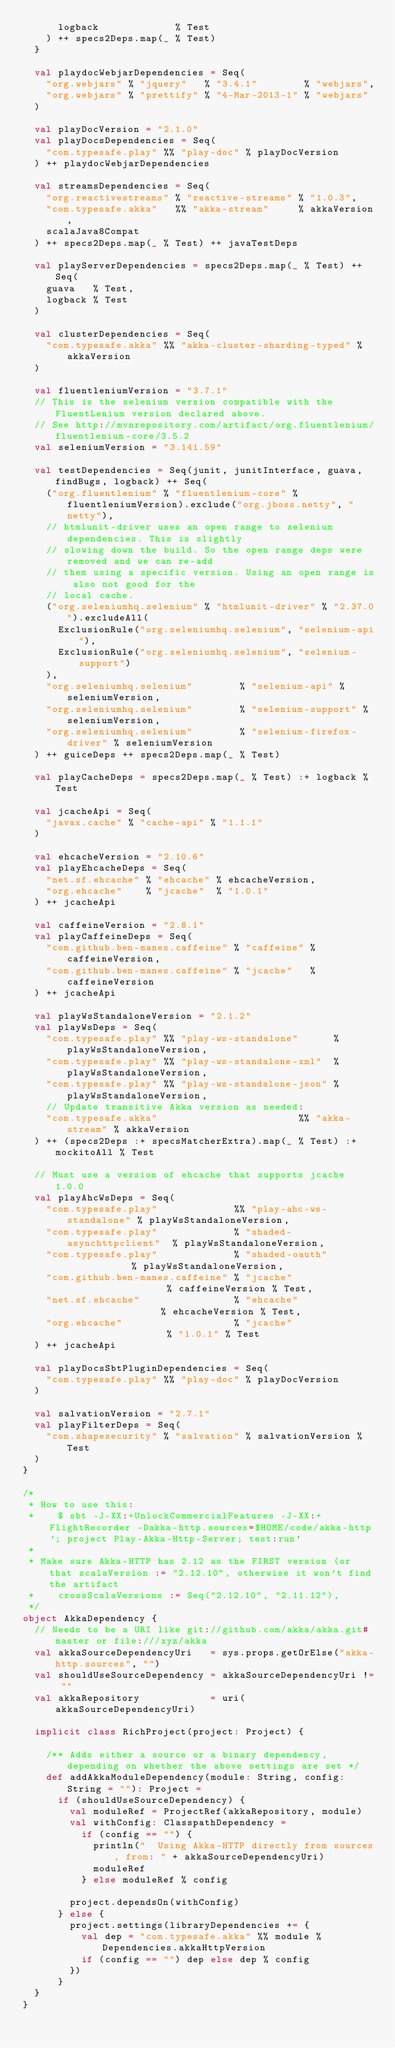Convert code to text. <code><loc_0><loc_0><loc_500><loc_500><_Scala_>      logback             % Test
    ) ++ specs2Deps.map(_ % Test)
  }

  val playdocWebjarDependencies = Seq(
    "org.webjars" % "jquery"   % "3.4.1"        % "webjars",
    "org.webjars" % "prettify" % "4-Mar-2013-1" % "webjars"
  )

  val playDocVersion = "2.1.0"
  val playDocsDependencies = Seq(
    "com.typesafe.play" %% "play-doc" % playDocVersion
  ) ++ playdocWebjarDependencies

  val streamsDependencies = Seq(
    "org.reactivestreams" % "reactive-streams" % "1.0.3",
    "com.typesafe.akka"   %% "akka-stream"     % akkaVersion,
    scalaJava8Compat
  ) ++ specs2Deps.map(_ % Test) ++ javaTestDeps

  val playServerDependencies = specs2Deps.map(_ % Test) ++ Seq(
    guava   % Test,
    logback % Test
  )

  val clusterDependencies = Seq(
    "com.typesafe.akka" %% "akka-cluster-sharding-typed" % akkaVersion
  )

  val fluentleniumVersion = "3.7.1"
  // This is the selenium version compatible with the FluentLenium version declared above.
  // See http://mvnrepository.com/artifact/org.fluentlenium/fluentlenium-core/3.5.2
  val seleniumVersion = "3.141.59"

  val testDependencies = Seq(junit, junitInterface, guava, findBugs, logback) ++ Seq(
    ("org.fluentlenium" % "fluentlenium-core" % fluentleniumVersion).exclude("org.jboss.netty", "netty"),
    // htmlunit-driver uses an open range to selenium dependencies. This is slightly
    // slowing down the build. So the open range deps were removed and we can re-add
    // them using a specific version. Using an open range is also not good for the
    // local cache.
    ("org.seleniumhq.selenium" % "htmlunit-driver" % "2.37.0").excludeAll(
      ExclusionRule("org.seleniumhq.selenium", "selenium-api"),
      ExclusionRule("org.seleniumhq.selenium", "selenium-support")
    ),
    "org.seleniumhq.selenium"        % "selenium-api" % seleniumVersion,
    "org.seleniumhq.selenium"        % "selenium-support" % seleniumVersion,
    "org.seleniumhq.selenium"        % "selenium-firefox-driver" % seleniumVersion
  ) ++ guiceDeps ++ specs2Deps.map(_ % Test)

  val playCacheDeps = specs2Deps.map(_ % Test) :+ logback % Test

  val jcacheApi = Seq(
    "javax.cache" % "cache-api" % "1.1.1"
  )

  val ehcacheVersion = "2.10.6"
  val playEhcacheDeps = Seq(
    "net.sf.ehcache" % "ehcache" % ehcacheVersion,
    "org.ehcache"    % "jcache"  % "1.0.1"
  ) ++ jcacheApi

  val caffeineVersion = "2.8.1"
  val playCaffeineDeps = Seq(
    "com.github.ben-manes.caffeine" % "caffeine" % caffeineVersion,
    "com.github.ben-manes.caffeine" % "jcache"   % caffeineVersion
  ) ++ jcacheApi

  val playWsStandaloneVersion = "2.1.2"
  val playWsDeps = Seq(
    "com.typesafe.play" %% "play-ws-standalone"      % playWsStandaloneVersion,
    "com.typesafe.play" %% "play-ws-standalone-xml"  % playWsStandaloneVersion,
    "com.typesafe.play" %% "play-ws-standalone-json" % playWsStandaloneVersion,
    // Update transitive Akka version as needed:
    "com.typesafe.akka"                        %% "akka-stream" % akkaVersion
  ) ++ (specs2Deps :+ specsMatcherExtra).map(_ % Test) :+ mockitoAll % Test

  // Must use a version of ehcache that supports jcache 1.0.0
  val playAhcWsDeps = Seq(
    "com.typesafe.play"             %% "play-ahc-ws-standalone" % playWsStandaloneVersion,
    "com.typesafe.play"             % "shaded-asynchttpclient"  % playWsStandaloneVersion,
    "com.typesafe.play"             % "shaded-oauth"            % playWsStandaloneVersion,
    "com.github.ben-manes.caffeine" % "jcache"                  % caffeineVersion % Test,
    "net.sf.ehcache"                % "ehcache"                 % ehcacheVersion % Test,
    "org.ehcache"                   % "jcache"                  % "1.0.1" % Test
  ) ++ jcacheApi

  val playDocsSbtPluginDependencies = Seq(
    "com.typesafe.play" %% "play-doc" % playDocVersion
  )

  val salvationVersion = "2.7.1"
  val playFilterDeps = Seq(
    "com.shapesecurity" % "salvation" % salvationVersion % Test
  )
}

/*
 * How to use this:
 *    $ sbt -J-XX:+UnlockCommercialFeatures -J-XX:+FlightRecorder -Dakka-http.sources=$HOME/code/akka-http '; project Play-Akka-Http-Server; test:run'
 *
 * Make sure Akka-HTTP has 2.12 as the FIRST version (or that scalaVersion := "2.12.10", otherwise it won't find the artifact
 *    crossScalaVersions := Seq("2.12.10", "2.11.12"),
 */
object AkkaDependency {
  // Needs to be a URI like git://github.com/akka/akka.git#master or file:///xyz/akka
  val akkaSourceDependencyUri   = sys.props.getOrElse("akka-http.sources", "")
  val shouldUseSourceDependency = akkaSourceDependencyUri != ""
  val akkaRepository            = uri(akkaSourceDependencyUri)

  implicit class RichProject(project: Project) {

    /** Adds either a source or a binary dependency, depending on whether the above settings are set */
    def addAkkaModuleDependency(module: String, config: String = ""): Project =
      if (shouldUseSourceDependency) {
        val moduleRef = ProjectRef(akkaRepository, module)
        val withConfig: ClasspathDependency =
          if (config == "") {
            println("  Using Akka-HTTP directly from sources, from: " + akkaSourceDependencyUri)
            moduleRef
          } else moduleRef % config

        project.dependsOn(withConfig)
      } else {
        project.settings(libraryDependencies += {
          val dep = "com.typesafe.akka" %% module % Dependencies.akkaHttpVersion
          if (config == "") dep else dep % config
        })
      }
  }
}
</code> 